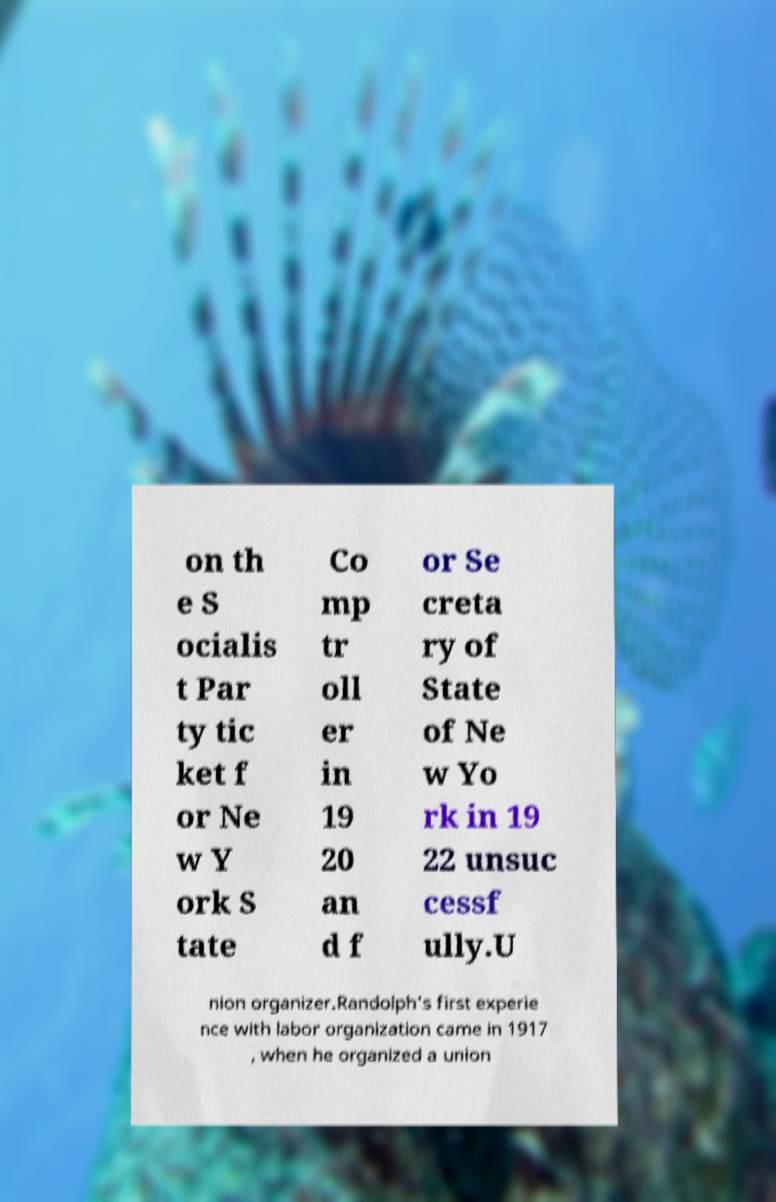Can you accurately transcribe the text from the provided image for me? on th e S ocialis t Par ty tic ket f or Ne w Y ork S tate Co mp tr oll er in 19 20 an d f or Se creta ry of State of Ne w Yo rk in 19 22 unsuc cessf ully.U nion organizer.Randolph's first experie nce with labor organization came in 1917 , when he organized a union 